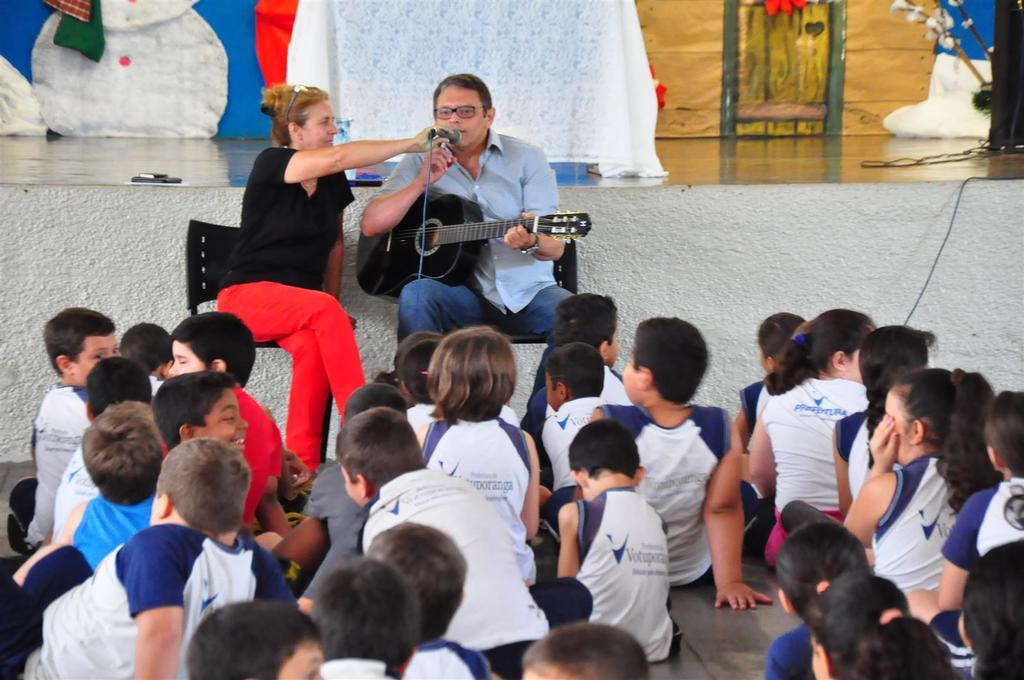What are the majority of the kids doing in the image? Most of the kids are sitting on the floor. How are the other two persons positioned in the image? Two persons are sitting on chairs. What is the person in front of the microphone doing? The person singing is in front of a microphone. What is the woman holding in the image? A woman is holding a microphone. What type of rod is the sister using to catch fish in the image? There is no sister or fishing rod present in the image. How does the person holding the guitar show respect to the audience? The image does not show any indication of the person showing respect to the audience, as it only depicts the person holding a guitar and singing. 